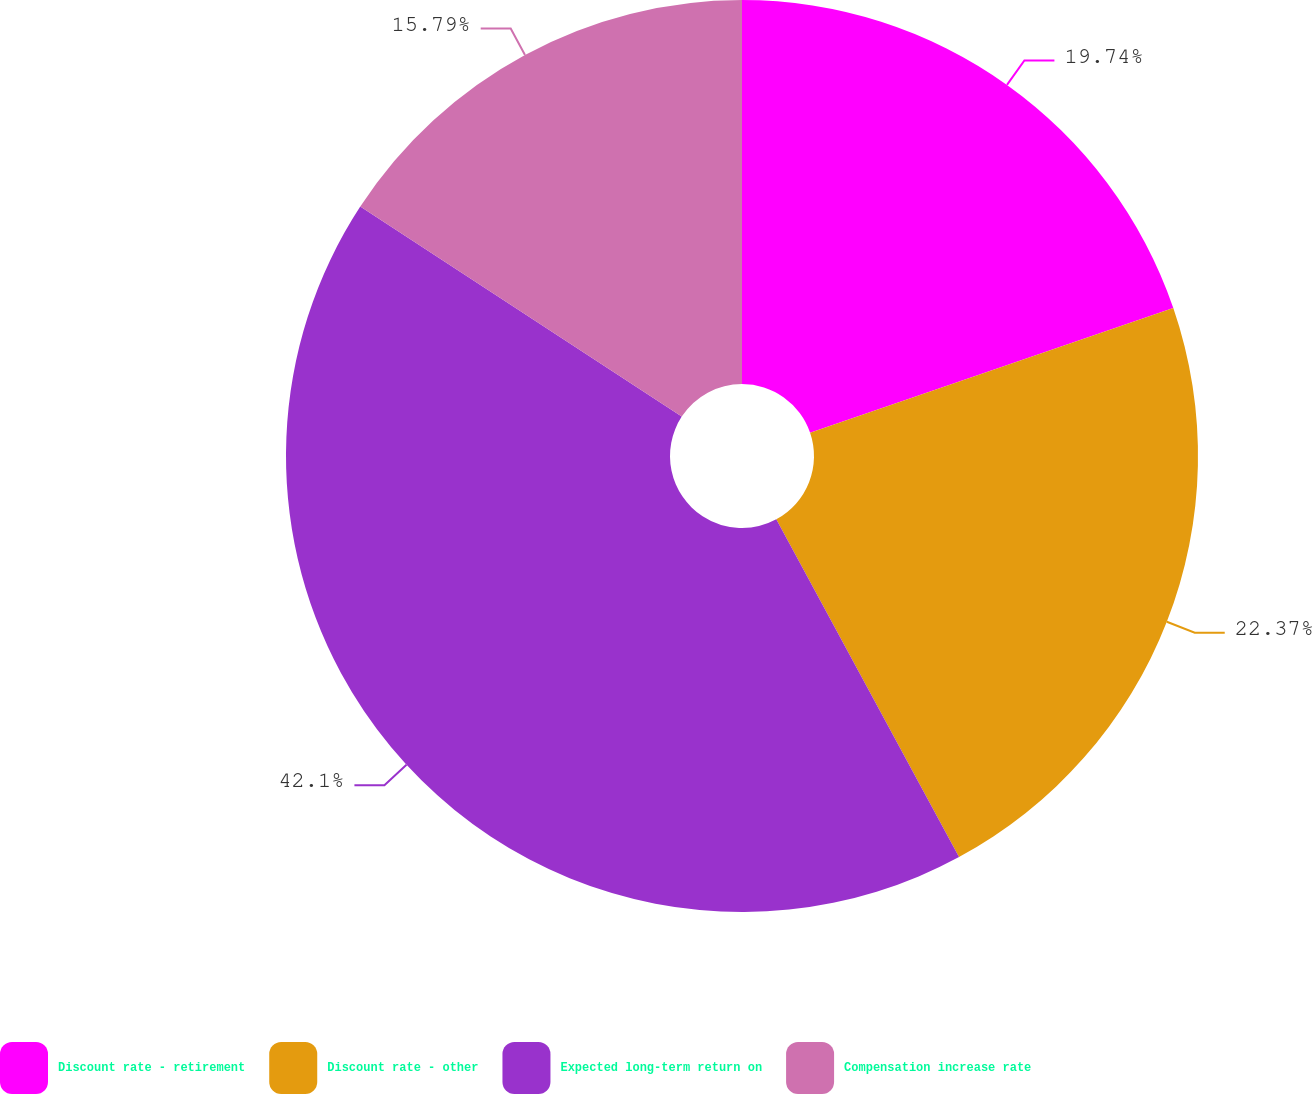<chart> <loc_0><loc_0><loc_500><loc_500><pie_chart><fcel>Discount rate - retirement<fcel>Discount rate - other<fcel>Expected long-term return on<fcel>Compensation increase rate<nl><fcel>19.74%<fcel>22.37%<fcel>42.11%<fcel>15.79%<nl></chart> 